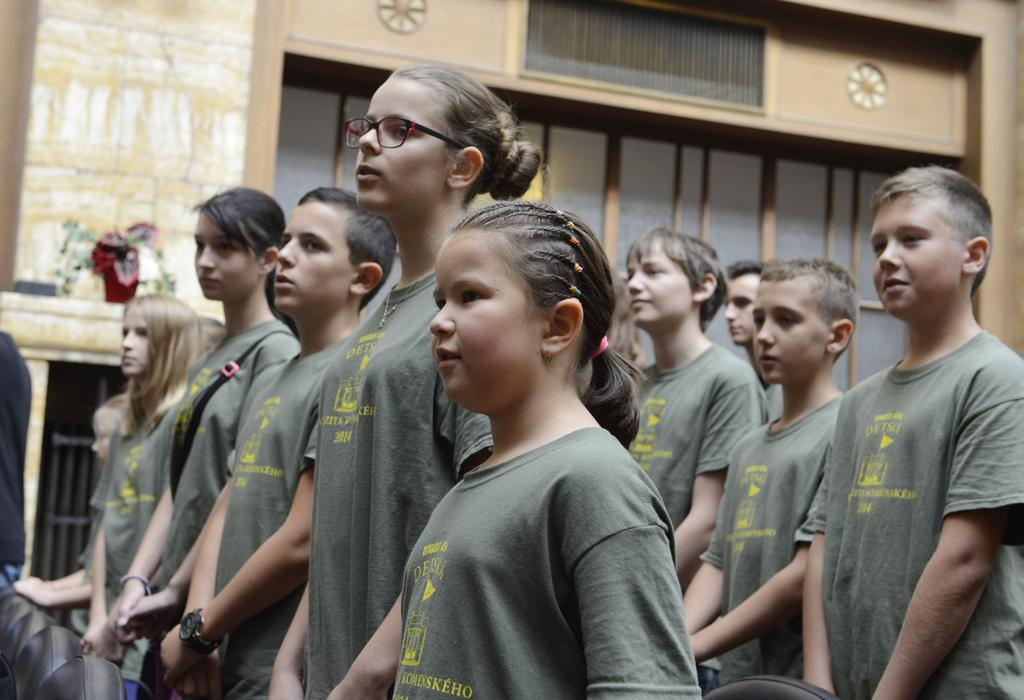What is the main subject of the image? The main subject of the image is people standing in the middle. Can you describe the background of the image? There is a wall visible behind the people. What scientific discovery is being celebrated in the image? There is no indication of a scientific discovery being celebrated in the image. What is the name of the person standing on the left side of the image? The provided facts do not include any names of the people in the image. 